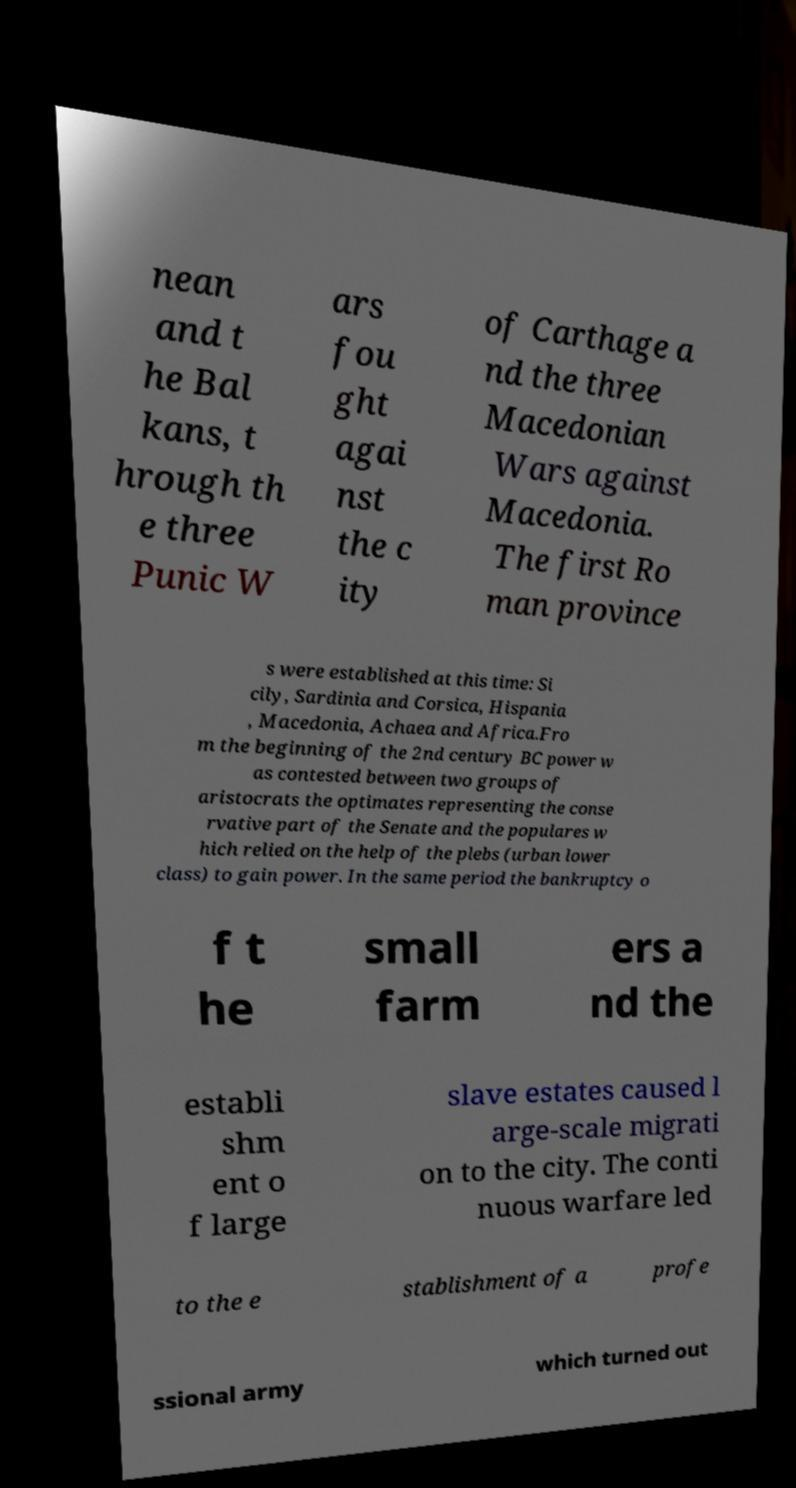What messages or text are displayed in this image? I need them in a readable, typed format. nean and t he Bal kans, t hrough th e three Punic W ars fou ght agai nst the c ity of Carthage a nd the three Macedonian Wars against Macedonia. The first Ro man province s were established at this time: Si cily, Sardinia and Corsica, Hispania , Macedonia, Achaea and Africa.Fro m the beginning of the 2nd century BC power w as contested between two groups of aristocrats the optimates representing the conse rvative part of the Senate and the populares w hich relied on the help of the plebs (urban lower class) to gain power. In the same period the bankruptcy o f t he small farm ers a nd the establi shm ent o f large slave estates caused l arge-scale migrati on to the city. The conti nuous warfare led to the e stablishment of a profe ssional army which turned out 